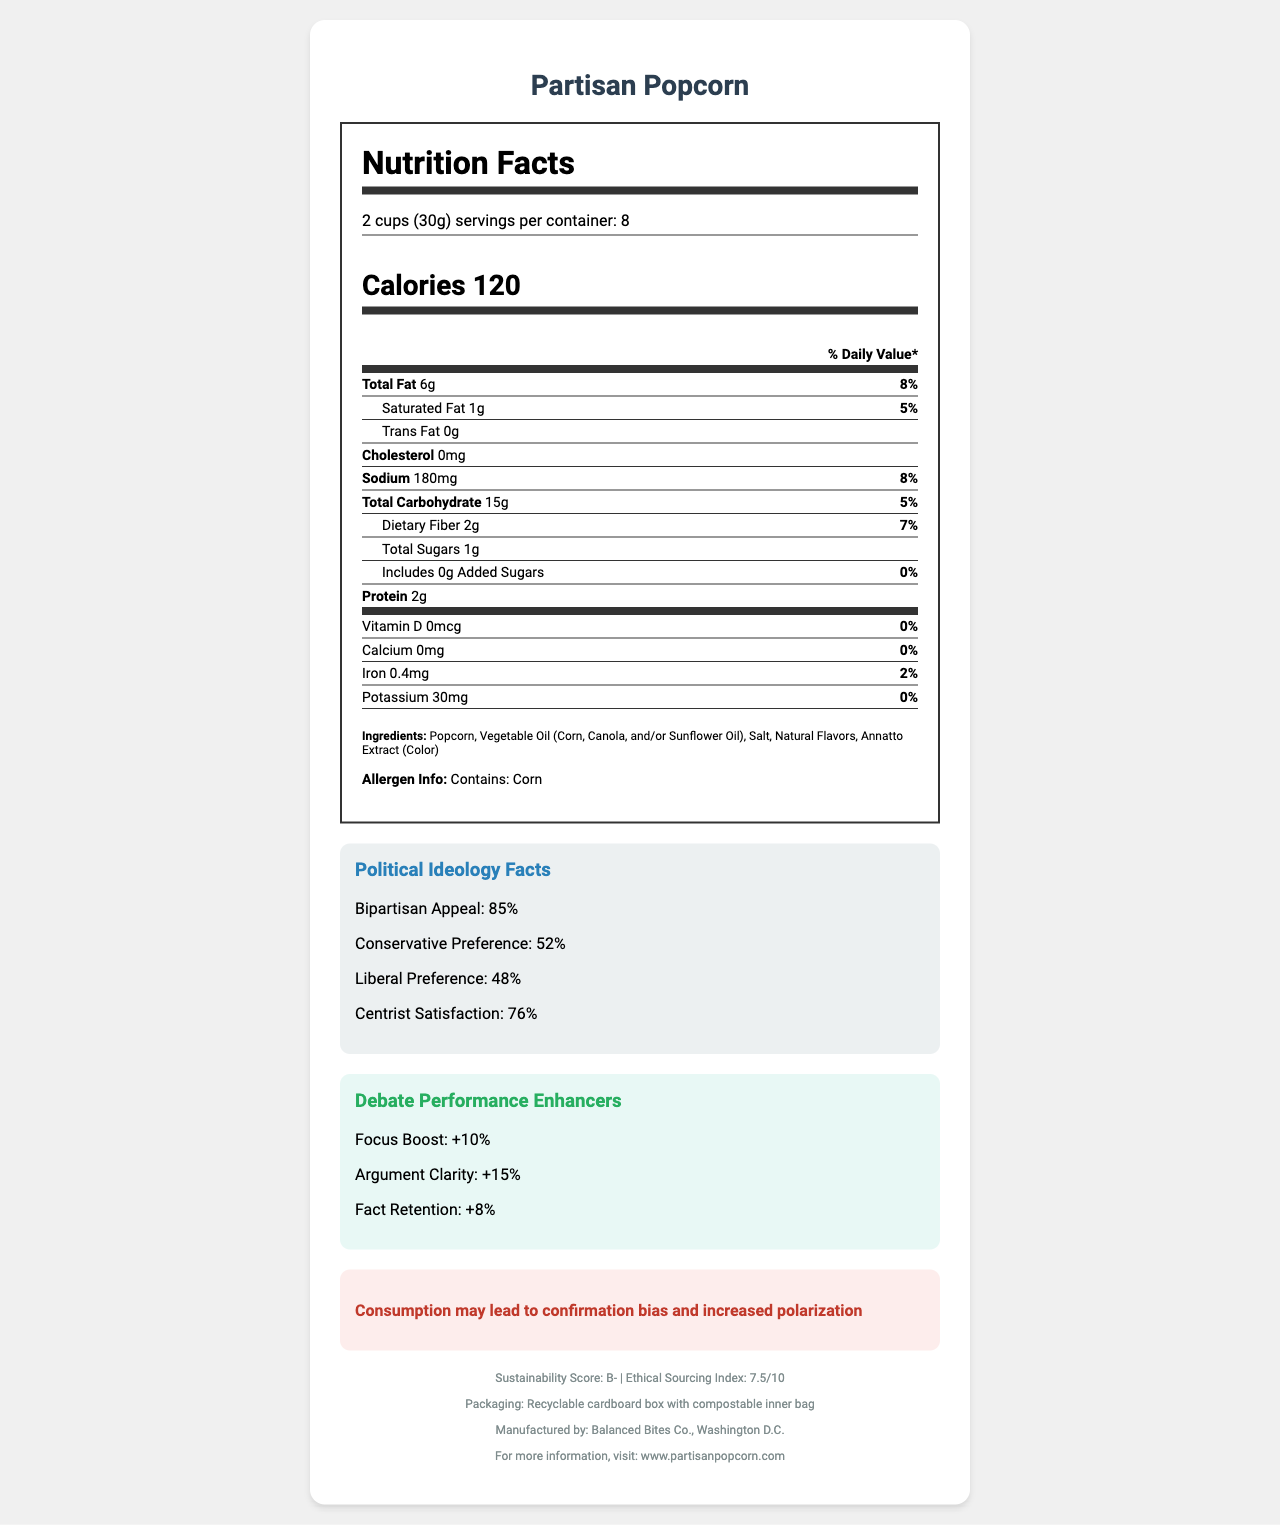What is the serving size of Partisan Popcorn? The document specifies that the serving size for Partisan Popcorn is 2 cups, which is equivalent to 30 grams.
Answer: 2 cups (30g) How many servings are there per container? The document states that there are 8 servings per container of Partisan Popcorn.
Answer: 8 What is the total fat content per serving? According to the document, each serving of Partisan Popcorn contains 6 grams of total fat.
Answer: 6g How much sodium does one serving contain? The document indicates that one serving of Partisan Popcorn contains 180 milligrams of sodium.
Answer: 180mg What percentage of the daily value of dietary fiber is provided by one serving? The document mentions that one serving of Partisan Popcorn provides 7% of the daily value of dietary fiber.
Answer: 7% What is the focus boost percentage mentioned under debate performance enhancers? The document highlights that consuming Partisan Popcorn can lead to a 10% focus boost during debates.
Answer: +10% How much protein is in each serving of Partisan Popcorn? The document states that each serving of Partisan Popcorn contains 2 grams of protein.
Answer: 2g Which nutrient has a daily value of 0% per serving? A. Calcium B. Vitamin D C. Added Sugars D. All of the above The document lists Vitamin D, Calcium, and Added Sugars as having a daily value of 0% per serving.
Answer: D. All of the above What is the cognitive bias warning mentioned in the document? A. Careless decision-making B. Increased polarization C. Uneven debate performance The document warns that consumption of Partisan Popcorn may lead to confirmation bias and increased polarization.
Answer: B. Increased polarization Is Partisan Popcorn suitable for a sodium-restricted diet? Each serving of Partisan Popcorn contains 180mg of sodium, which may be too high for individuals on a sodium-restricted diet.
Answer: No Does the product contain any allergens? According to the document, Partisan Popcorn contains corn.
Answer: Yes Which preference is highest for Partisan Popcorn? The document states that the bipartisan appeal of Partisan Popcorn is 85%, which is higher than conservative preference, liberal preference, and centrist satisfaction.
Answer: Bipartisan Appeal Where is Partisan Popcorn manufactured? The document indicates that Partisan Popcorn is manufactured by Balanced Bites Co., located in Washington D.C.
Answer: Washington D.C. Can the nutritional information of Partisan Popcorn be found on its website? The document provides the website www.partisanpopcorn.com for more information.
Answer: Yes How is the packaging designed to be environmentally friendly? The document mentions that the packaging of Partisan Popcorn is a recyclable cardboard box with a compostable inner bag.
Answer: Recyclable cardboard box with compostable inner bag Summarize the main ideas presented in the document. The document offers comprehensive information about Partisan Popcorn, covering nutrition, political appeal, debate performance, and sustainability features, along with manufacturer details and contact information.
Answer: The document provides detailed nutritional information, including serving size, calorie count, and nutrient content per serving for Partisan Popcorn. It also includes political ideology facts, debate performance enhancers, a cognitive bias warning, sustainability and ethical sourcing scores, allergen information, and packaging details. The product is manufactured by Balanced Bites Co. in Washington D.C., and additional information is available on their website. Which political party prefers Partisan Popcorn more? The document provides percentages for conservative and liberal preferences but does not indicate a significant difference (52% vs. 48%) nor explicit favoritism for one party over another.
Answer: Not enough information 